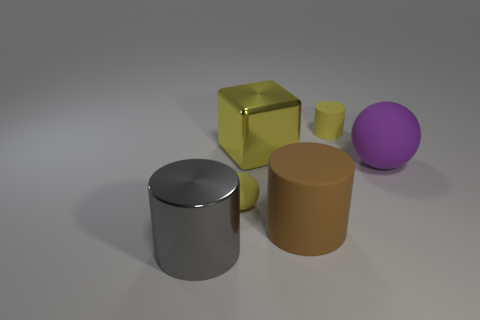Add 3 brown things. How many objects exist? 9 Subtract all cubes. How many objects are left? 5 Subtract 0 gray cubes. How many objects are left? 6 Subtract all large shiny things. Subtract all large brown rubber cylinders. How many objects are left? 3 Add 2 yellow shiny blocks. How many yellow shiny blocks are left? 3 Add 6 small spheres. How many small spheres exist? 7 